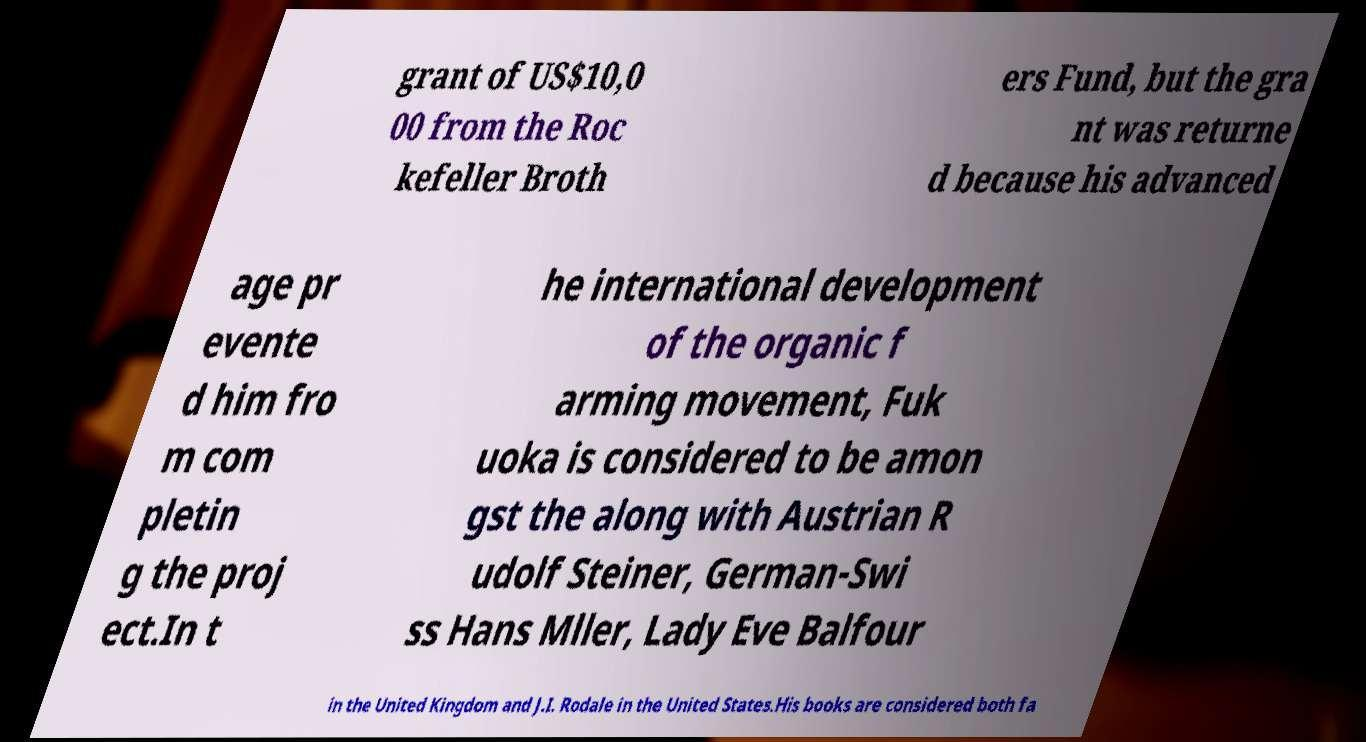There's text embedded in this image that I need extracted. Can you transcribe it verbatim? grant of US$10,0 00 from the Roc kefeller Broth ers Fund, but the gra nt was returne d because his advanced age pr evente d him fro m com pletin g the proj ect.In t he international development of the organic f arming movement, Fuk uoka is considered to be amon gst the along with Austrian R udolf Steiner, German-Swi ss Hans Mller, Lady Eve Balfour in the United Kingdom and J.I. Rodale in the United States.His books are considered both fa 